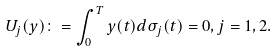Convert formula to latex. <formula><loc_0><loc_0><loc_500><loc_500>U _ { j } ( y ) \colon = \int _ { 0 } ^ { T } y ( t ) d \sigma _ { j } ( t ) = 0 , j = 1 , 2 .</formula> 